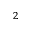Convert formula to latex. <formula><loc_0><loc_0><loc_500><loc_500>^ { 2 }</formula> 